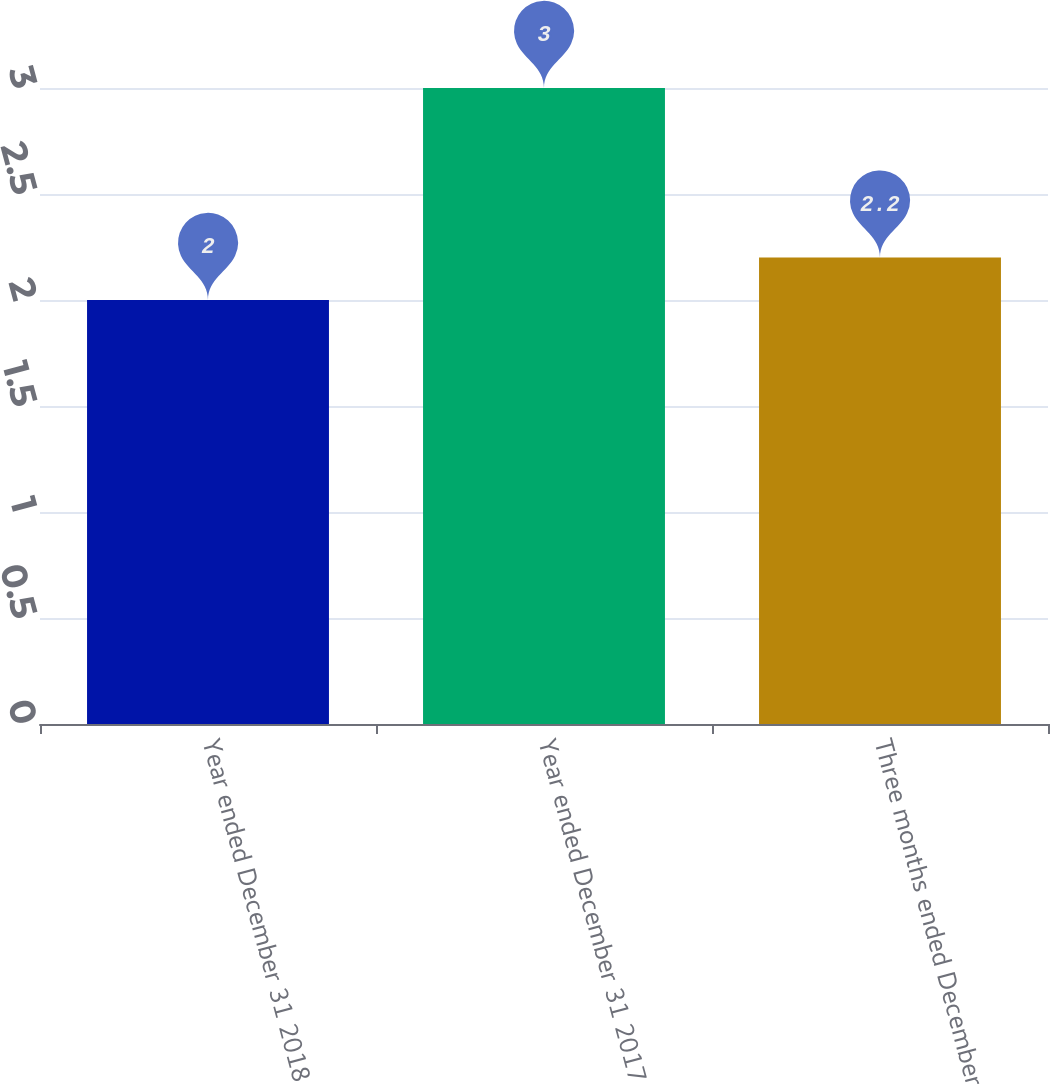Convert chart to OTSL. <chart><loc_0><loc_0><loc_500><loc_500><bar_chart><fcel>Year ended December 31 2018<fcel>Year ended December 31 2017<fcel>Three months ended December 31<nl><fcel>2<fcel>3<fcel>2.2<nl></chart> 